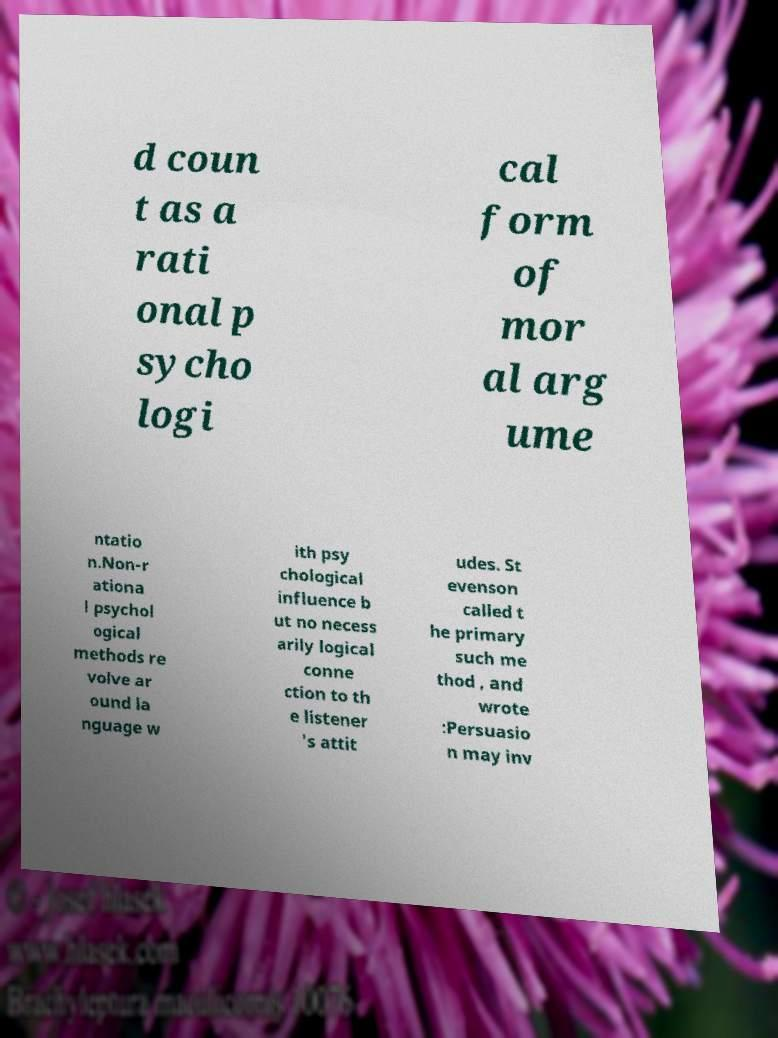Please identify and transcribe the text found in this image. d coun t as a rati onal p sycho logi cal form of mor al arg ume ntatio n.Non-r ationa l psychol ogical methods re volve ar ound la nguage w ith psy chological influence b ut no necess arily logical conne ction to th e listener 's attit udes. St evenson called t he primary such me thod , and wrote :Persuasio n may inv 